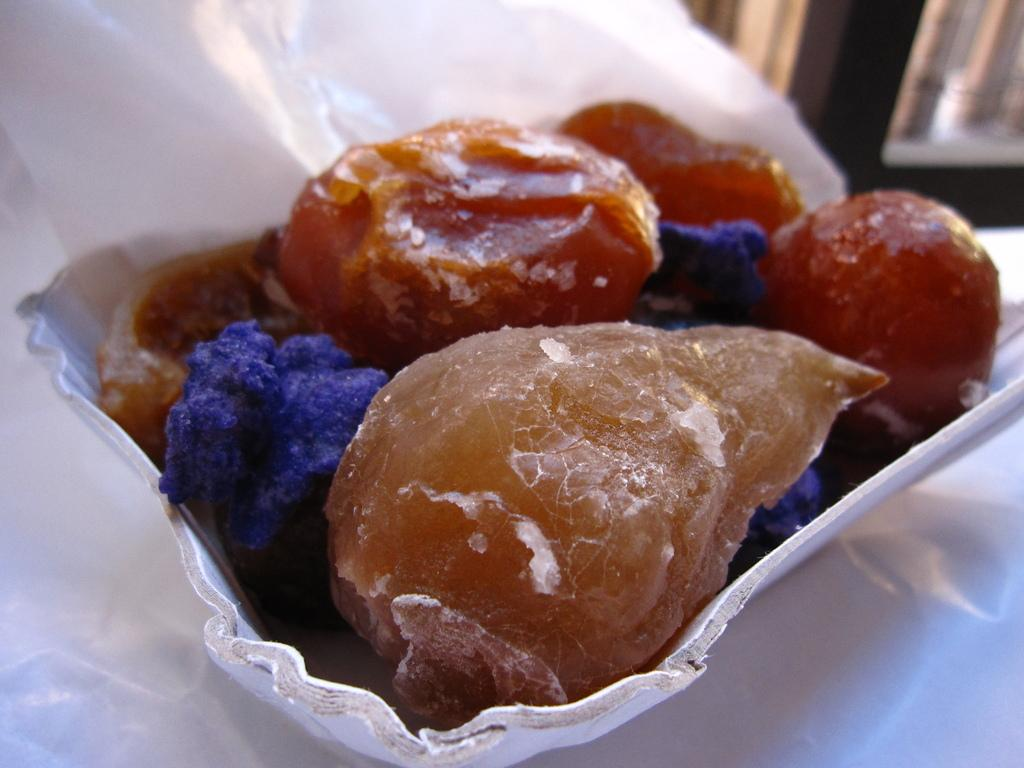What color is the bowl that is visible in the image? There is a white bowl in the image. What is inside the white bowl? There is food in the white bowl. Where is the white bowl placed in the image? The white bowl is placed on a white surface. Can you describe the background of the image? The background of the image is blurred. What kind of trouble is the woman experiencing in the image? There is no woman present in the image, and therefore no trouble can be observed. 